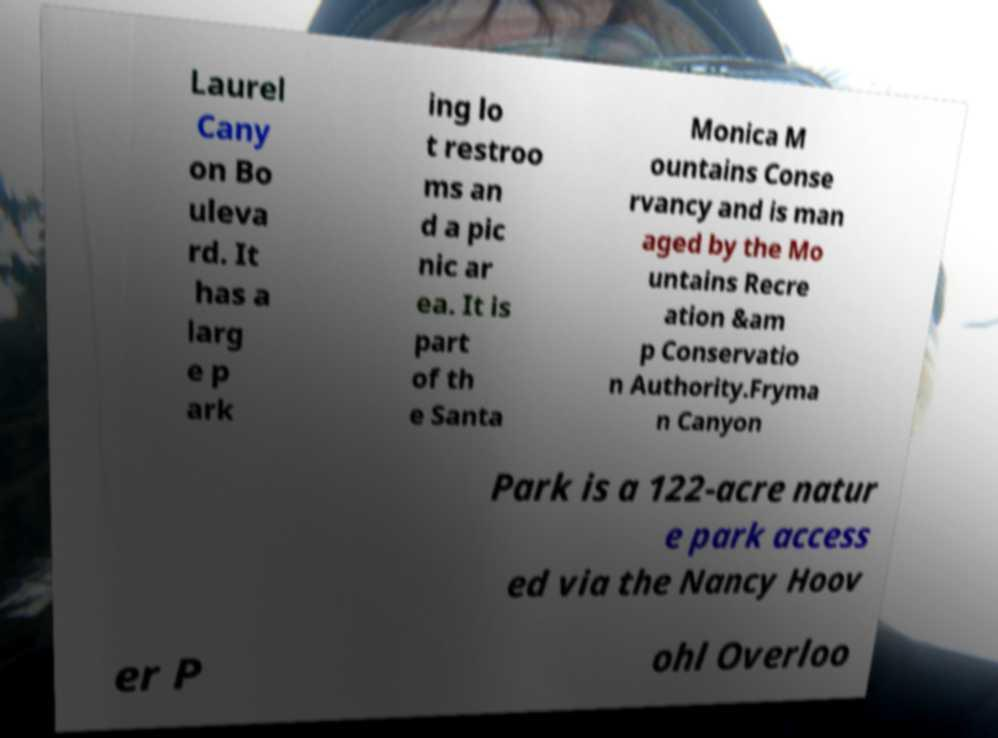There's text embedded in this image that I need extracted. Can you transcribe it verbatim? Laurel Cany on Bo uleva rd. It has a larg e p ark ing lo t restroo ms an d a pic nic ar ea. It is part of th e Santa Monica M ountains Conse rvancy and is man aged by the Mo untains Recre ation &am p Conservatio n Authority.Fryma n Canyon Park is a 122-acre natur e park access ed via the Nancy Hoov er P ohl Overloo 